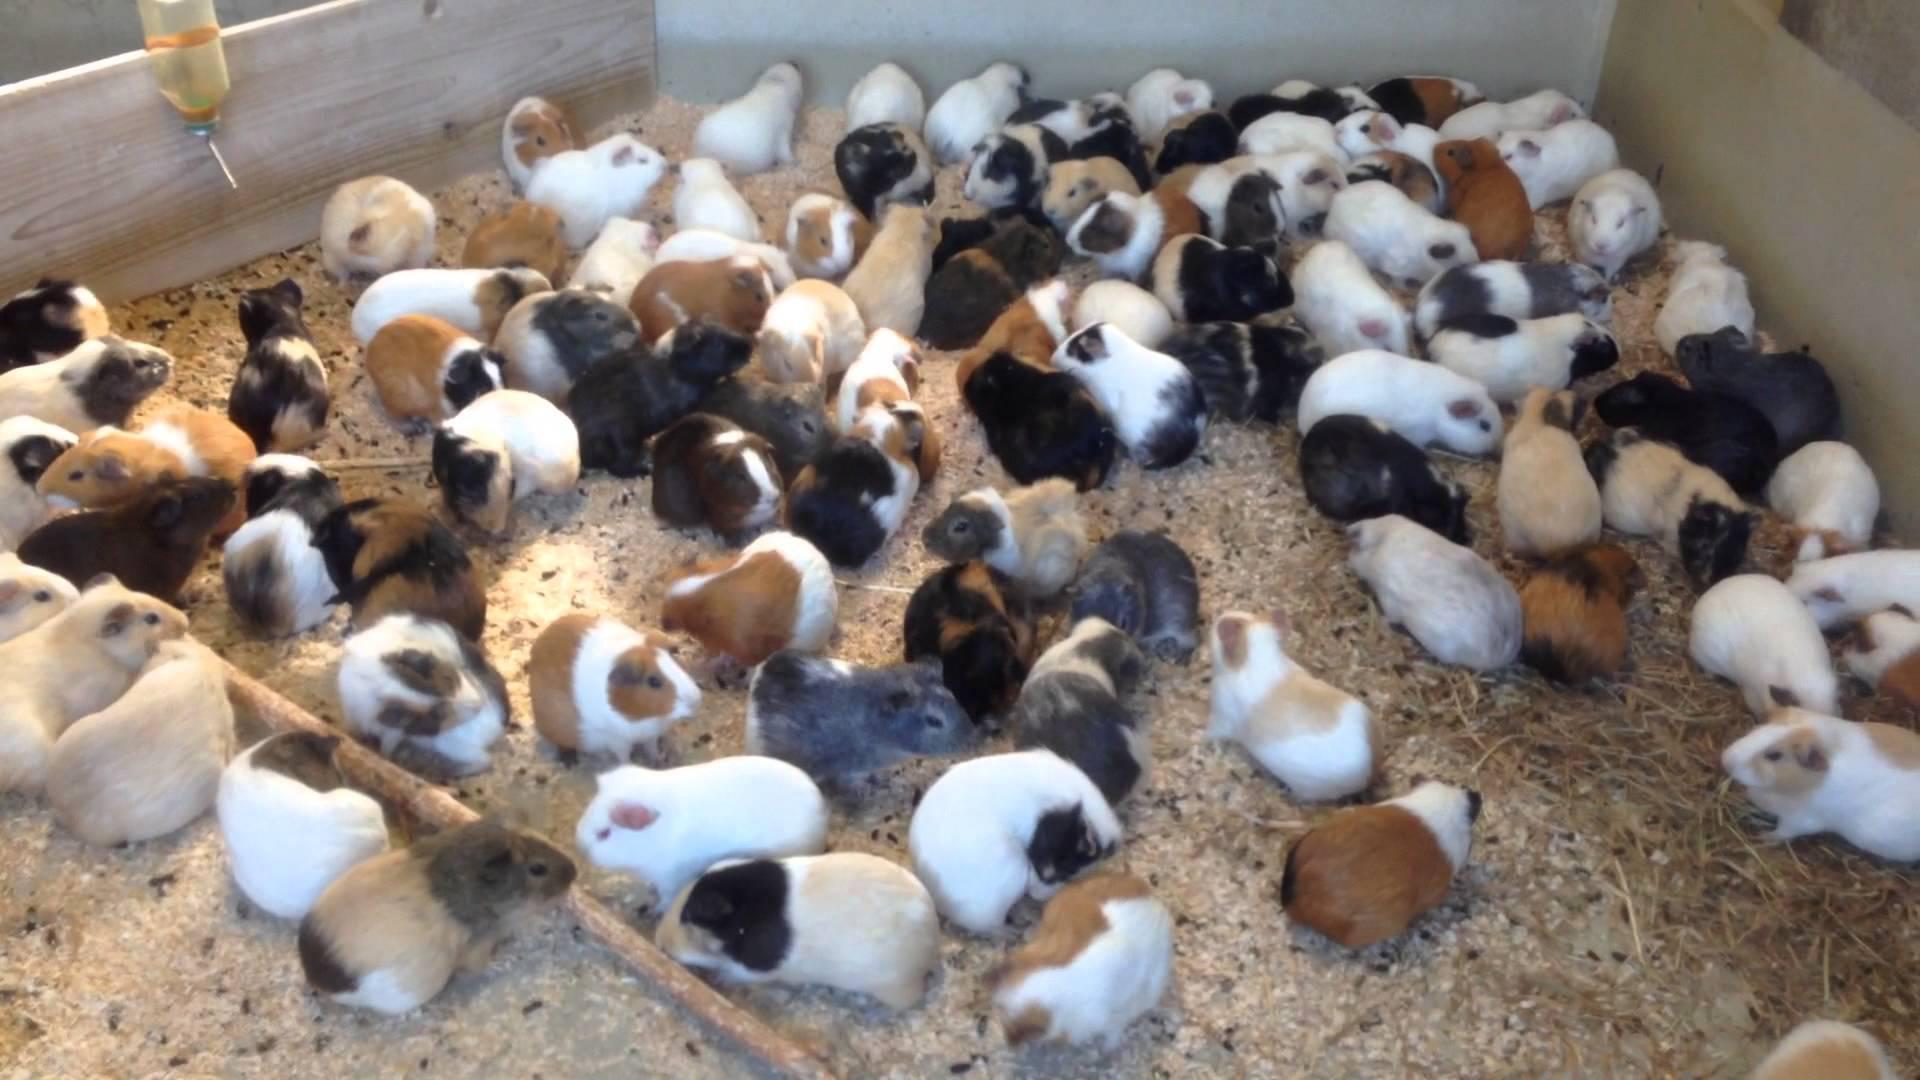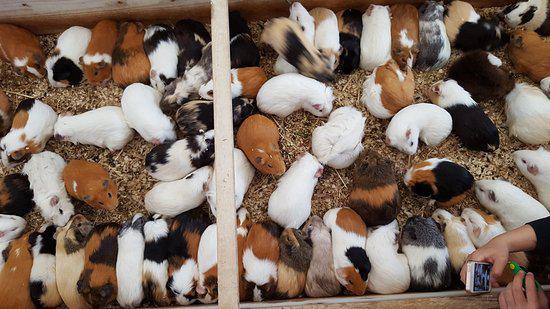The first image is the image on the left, the second image is the image on the right. Analyze the images presented: Is the assertion "One image includes no more than five hamsters." valid? Answer yes or no. No. The first image is the image on the left, the second image is the image on the right. Considering the images on both sides, is "The guinea pigs are eating in both images and are eating fresh green vegetation in one of the images." valid? Answer yes or no. No. 